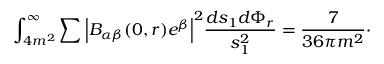Convert formula to latex. <formula><loc_0><loc_0><loc_500><loc_500>\int _ { 4 m ^ { 2 } } ^ { \infty } \sum \left | B _ { \alpha \beta } ( 0 , r ) e ^ { \beta } \right | ^ { 2 } \frac { d s _ { 1 } d \Phi _ { r } } { s _ { 1 } ^ { 2 } } = \frac { 7 } { 3 6 \pi m ^ { 2 } } \cdot</formula> 